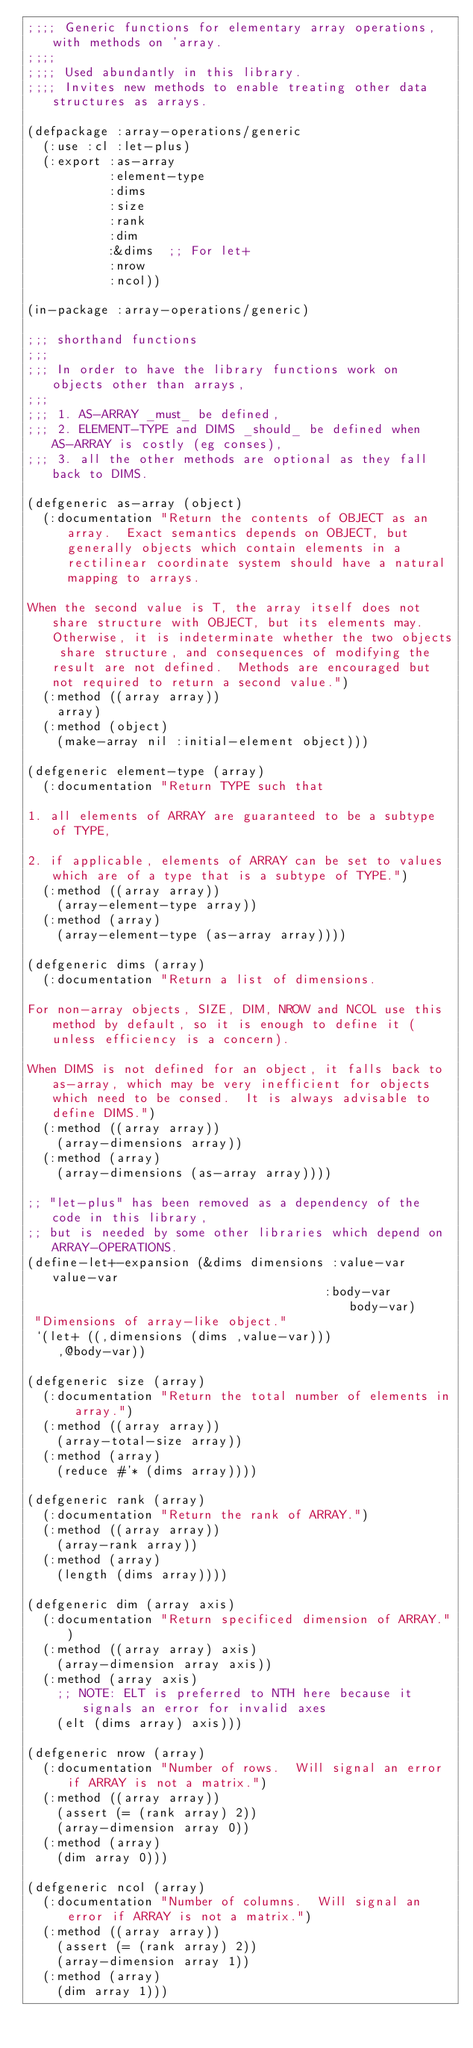Convert code to text. <code><loc_0><loc_0><loc_500><loc_500><_Lisp_>;;;; Generic functions for elementary array operations, with methods on 'array.
;;;;
;;;; Used abundantly in this library.
;;;; Invites new methods to enable treating other data structures as arrays.

(defpackage :array-operations/generic
  (:use :cl :let-plus)
  (:export :as-array
           :element-type
           :dims
           :size
           :rank
           :dim
           :&dims  ;; For let+
           :nrow
           :ncol))

(in-package :array-operations/generic)

;;; shorthand functions
;;;
;;; In order to have the library functions work on objects other than arrays,
;;;
;;; 1. AS-ARRAY _must_ be defined,
;;; 2. ELEMENT-TYPE and DIMS _should_ be defined when AS-ARRAY is costly (eg conses),
;;; 3. all the other methods are optional as they fall back to DIMS.

(defgeneric as-array (object)
  (:documentation "Return the contents of OBJECT as an array.  Exact semantics depends on OBJECT, but generally objects which contain elements in a rectilinear coordinate system should have a natural mapping to arrays.

When the second value is T, the array itself does not share structure with OBJECT, but its elements may.  Otherwise, it is indeterminate whether the two objects share structure, and consequences of modifying the result are not defined.  Methods are encouraged but not required to return a second value.")
  (:method ((array array))
    array)
  (:method (object)
    (make-array nil :initial-element object)))

(defgeneric element-type (array)
  (:documentation "Return TYPE such that

1. all elements of ARRAY are guaranteed to be a subtype of TYPE,

2. if applicable, elements of ARRAY can be set to values which are of a type that is a subtype of TYPE.")
  (:method ((array array))
    (array-element-type array))
  (:method (array)
    (array-element-type (as-array array))))

(defgeneric dims (array)
  (:documentation "Return a list of dimensions.

For non-array objects, SIZE, DIM, NROW and NCOL use this method by default, so it is enough to define it (unless efficiency is a concern).

When DIMS is not defined for an object, it falls back to as-array, which may be very inefficient for objects which need to be consed.  It is always advisable to define DIMS.")
  (:method ((array array))
    (array-dimensions array))
  (:method (array)
    (array-dimensions (as-array array))))

;; "let-plus" has been removed as a dependency of the code in this library,
;; but is needed by some other libraries which depend on ARRAY-OPERATIONS.
(define-let+-expansion (&dims dimensions :value-var value-var
                                        :body-var body-var)
 "Dimensions of array-like object."
 `(let+ ((,dimensions (dims ,value-var)))
    ,@body-var))

(defgeneric size (array)
  (:documentation "Return the total number of elements in array.")
  (:method ((array array))
    (array-total-size array))
  (:method (array)
    (reduce #'* (dims array))))

(defgeneric rank (array)
  (:documentation "Return the rank of ARRAY.")
  (:method ((array array))
    (array-rank array))
  (:method (array)
    (length (dims array))))

(defgeneric dim (array axis)
  (:documentation "Return specificed dimension of ARRAY.")
  (:method ((array array) axis)
    (array-dimension array axis))
  (:method (array axis)
    ;; NOTE: ELT is preferred to NTH here because it signals an error for invalid axes
    (elt (dims array) axis)))

(defgeneric nrow (array)
  (:documentation "Number of rows.  Will signal an error if ARRAY is not a matrix.")
  (:method ((array array))
    (assert (= (rank array) 2))
    (array-dimension array 0))
  (:method (array)
    (dim array 0)))

(defgeneric ncol (array)
  (:documentation "Number of columns.  Will signal an error if ARRAY is not a matrix.")
  (:method ((array array))
    (assert (= (rank array) 2))
    (array-dimension array 1))
  (:method (array)
    (dim array 1)))
</code> 